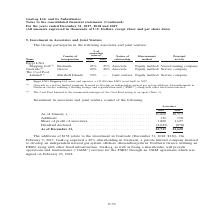According to Gaslog's financial document, How many percent of shareholding in Gastrade did GasLog acquire? According to the financial document, 20%. The relevant text states: "method Vessel-owning company Gastrade (2) . Greece 20% 20% Associate Equity method Service company The Cool Pool Limited (3) . Marshall Islands 50% — Joint..." Also, Which country will the development of an independent natural gas system take place? According to the financial document, Greece. The relevant text states: "quity method Vessel-owning company Gastrade (2) . Greece 20% 20% Associate Equity method Service company The Cool Pool Limited (3) . Marshall Islands 50% —..." Also, In which years was the investments recorded for? The document shows two values: 2018 and 2019. From the document: ") For the years ended December 31, 2017, 2018 and 2019 (All amounts expressed in thousands of U.S. Dollars, except share and per share data) Continued..." Additionally, In which year was the dividend declared higher? According to the financial document, 2018. The relevant text states: "Continued) For the years ended December 31, 2017, 2018 and 2019 (All amounts expressed in thousands of U.S. Dollars, except share and per share data)..." Also, can you calculate: What was the change in additions from 2018 to 2019? Based on the calculation: 158 - 136 , the result is 22 (in thousands). This is based on the information: "As of January 1, . 20,800 20,713 Additions . 136 158 Share of profit of associates . 1,800 1,627 Dividend declared . (2,023) (878) As of January 1, . 20,800 20,713 Additions . 136 158 Share of profit ..." The key data points involved are: 136, 158. Also, can you calculate: What was the percentage change in share of profit of associates from 2018 to 2019? To answer this question, I need to perform calculations using the financial data. The calculation is: (1,627 - 1,800)/1,800 , which equals -9.61 (percentage). This is based on the information: "ditions . 136 158 Share of profit of associates . 1,800 1,627 Dividend declared . (2,023) (878) s . 136 158 Share of profit of associates . 1,800 1,627 Dividend declared . (2,023) (878)..." The key data points involved are: 1,627, 1,800. 